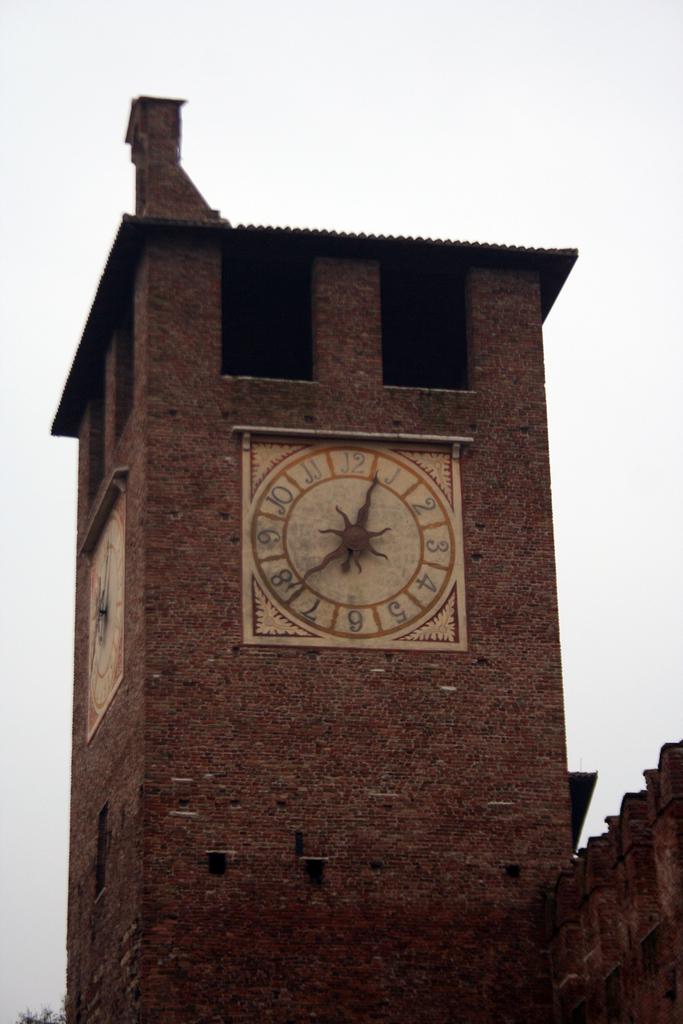What number is the minute hand pointing to on the clock?
Offer a very short reply. 8. What time is it?
Your answer should be very brief. 12:40. 